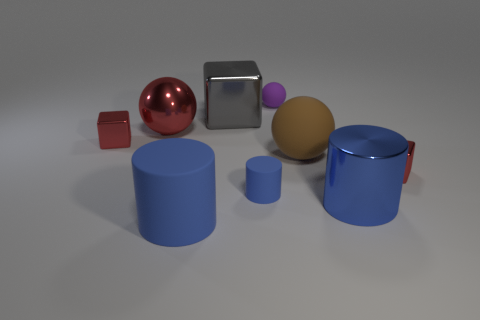Subtract all red blocks. Subtract all gray cylinders. How many blocks are left? 1 Add 1 cylinders. How many objects exist? 10 Subtract all balls. How many objects are left? 6 Add 9 big gray cubes. How many big gray cubes exist? 10 Subtract 0 red cylinders. How many objects are left? 9 Subtract all rubber things. Subtract all tiny purple matte objects. How many objects are left? 4 Add 5 large gray metallic things. How many large gray metallic things are left? 6 